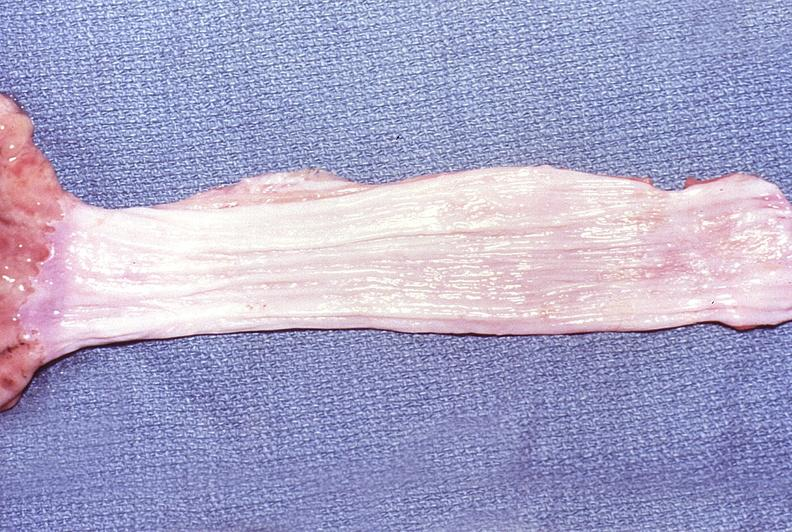where does this belong to?
Answer the question using a single word or phrase. Gastrointestinal system 